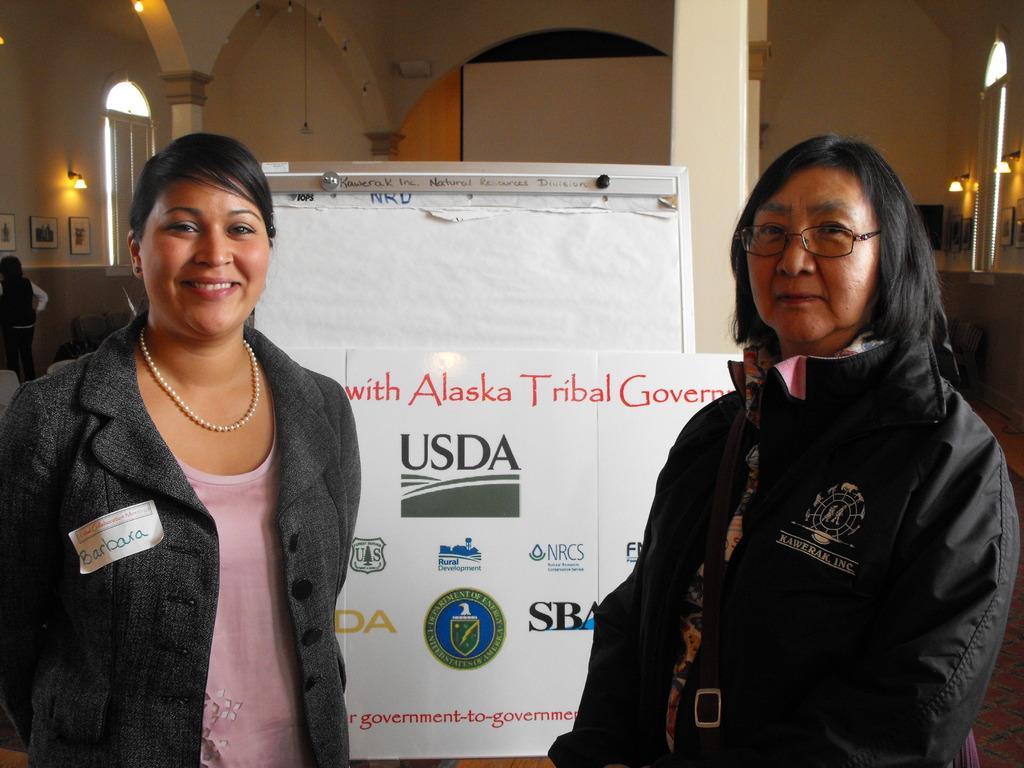Could you give a brief overview of what you see in this image? In this image I can see two persons. There are pillars, photo frames attached to the walls, and there are lights. Also there is a board. 